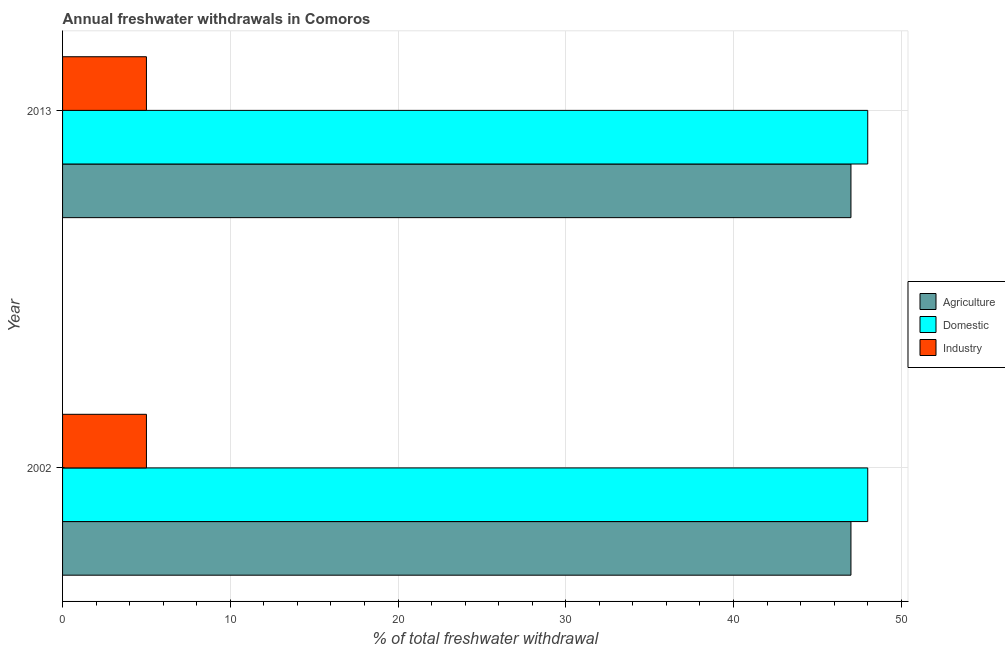How many bars are there on the 1st tick from the top?
Ensure brevity in your answer.  3. How many bars are there on the 1st tick from the bottom?
Offer a very short reply. 3. What is the label of the 1st group of bars from the top?
Your response must be concise. 2013. In how many cases, is the number of bars for a given year not equal to the number of legend labels?
Keep it short and to the point. 0. What is the percentage of freshwater withdrawal for industry in 2002?
Give a very brief answer. 5. Across all years, what is the maximum percentage of freshwater withdrawal for domestic purposes?
Ensure brevity in your answer.  48. Across all years, what is the minimum percentage of freshwater withdrawal for agriculture?
Offer a terse response. 47. In which year was the percentage of freshwater withdrawal for agriculture minimum?
Your answer should be compact. 2002. What is the total percentage of freshwater withdrawal for industry in the graph?
Your response must be concise. 10. What is the difference between the percentage of freshwater withdrawal for agriculture in 2002 and the percentage of freshwater withdrawal for industry in 2013?
Give a very brief answer. 42. In the year 2013, what is the difference between the percentage of freshwater withdrawal for domestic purposes and percentage of freshwater withdrawal for industry?
Give a very brief answer. 43. What is the ratio of the percentage of freshwater withdrawal for agriculture in 2002 to that in 2013?
Your response must be concise. 1. Is the percentage of freshwater withdrawal for agriculture in 2002 less than that in 2013?
Your answer should be compact. No. Is the difference between the percentage of freshwater withdrawal for industry in 2002 and 2013 greater than the difference between the percentage of freshwater withdrawal for agriculture in 2002 and 2013?
Offer a very short reply. No. What does the 2nd bar from the top in 2013 represents?
Keep it short and to the point. Domestic. What does the 2nd bar from the bottom in 2013 represents?
Your answer should be very brief. Domestic. Is it the case that in every year, the sum of the percentage of freshwater withdrawal for agriculture and percentage of freshwater withdrawal for domestic purposes is greater than the percentage of freshwater withdrawal for industry?
Give a very brief answer. Yes. Are all the bars in the graph horizontal?
Keep it short and to the point. Yes. How many years are there in the graph?
Keep it short and to the point. 2. Are the values on the major ticks of X-axis written in scientific E-notation?
Your response must be concise. No. Does the graph contain any zero values?
Give a very brief answer. No. Does the graph contain grids?
Offer a terse response. Yes. How many legend labels are there?
Your answer should be very brief. 3. What is the title of the graph?
Ensure brevity in your answer.  Annual freshwater withdrawals in Comoros. Does "Tertiary education" appear as one of the legend labels in the graph?
Offer a terse response. No. What is the label or title of the X-axis?
Keep it short and to the point. % of total freshwater withdrawal. What is the % of total freshwater withdrawal in Agriculture in 2002?
Provide a short and direct response. 47. What is the % of total freshwater withdrawal in Domestic in 2002?
Your response must be concise. 48. What is the % of total freshwater withdrawal in Industry in 2002?
Keep it short and to the point. 5. What is the % of total freshwater withdrawal of Domestic in 2013?
Give a very brief answer. 48. What is the % of total freshwater withdrawal in Industry in 2013?
Keep it short and to the point. 5. Across all years, what is the maximum % of total freshwater withdrawal in Domestic?
Offer a very short reply. 48. Across all years, what is the minimum % of total freshwater withdrawal of Domestic?
Your answer should be compact. 48. What is the total % of total freshwater withdrawal in Agriculture in the graph?
Provide a succinct answer. 94. What is the total % of total freshwater withdrawal in Domestic in the graph?
Your response must be concise. 96. What is the difference between the % of total freshwater withdrawal in Agriculture in 2002 and that in 2013?
Ensure brevity in your answer.  0. What is the difference between the % of total freshwater withdrawal in Domestic in 2002 and that in 2013?
Ensure brevity in your answer.  0. What is the difference between the % of total freshwater withdrawal of Industry in 2002 and that in 2013?
Give a very brief answer. 0. What is the difference between the % of total freshwater withdrawal of Agriculture in 2002 and the % of total freshwater withdrawal of Industry in 2013?
Provide a short and direct response. 42. What is the average % of total freshwater withdrawal of Domestic per year?
Keep it short and to the point. 48. In the year 2002, what is the difference between the % of total freshwater withdrawal of Agriculture and % of total freshwater withdrawal of Domestic?
Provide a short and direct response. -1. In the year 2013, what is the difference between the % of total freshwater withdrawal of Agriculture and % of total freshwater withdrawal of Domestic?
Give a very brief answer. -1. What is the ratio of the % of total freshwater withdrawal of Domestic in 2002 to that in 2013?
Offer a terse response. 1. What is the ratio of the % of total freshwater withdrawal of Industry in 2002 to that in 2013?
Ensure brevity in your answer.  1. What is the difference between the highest and the second highest % of total freshwater withdrawal of Agriculture?
Offer a very short reply. 0. What is the difference between the highest and the lowest % of total freshwater withdrawal in Agriculture?
Offer a very short reply. 0. What is the difference between the highest and the lowest % of total freshwater withdrawal in Domestic?
Keep it short and to the point. 0. 